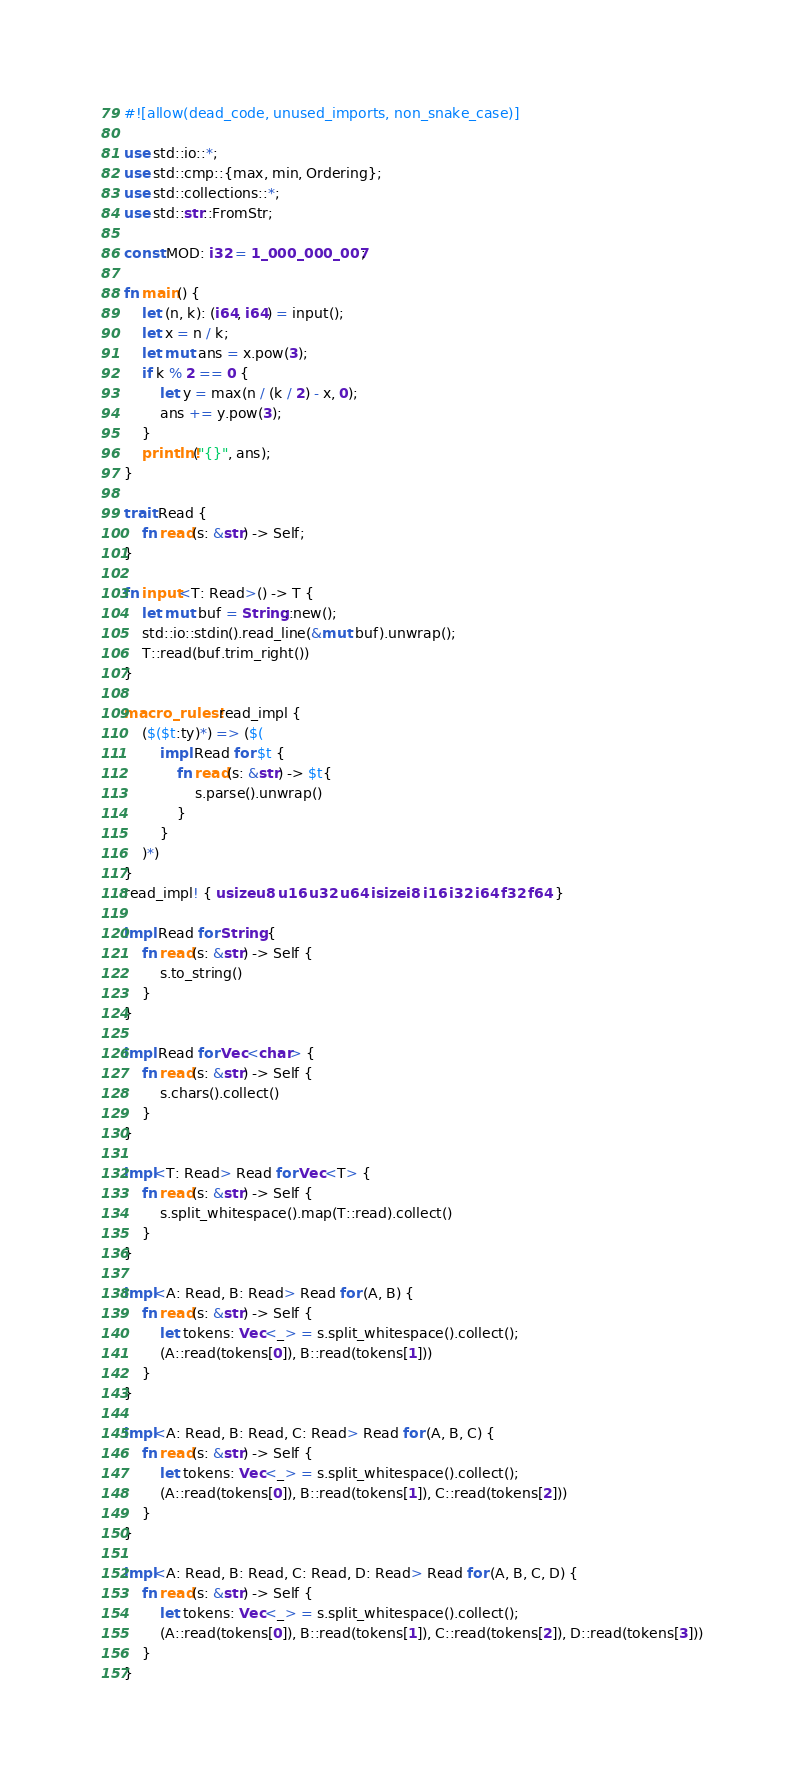Convert code to text. <code><loc_0><loc_0><loc_500><loc_500><_Rust_>#![allow(dead_code, unused_imports, non_snake_case)]

use std::io::*;
use std::cmp::{max, min, Ordering};
use std::collections::*;
use std::str::FromStr;

const MOD: i32 = 1_000_000_007;

fn main() {
    let (n, k): (i64, i64) = input();
    let x = n / k;
    let mut ans = x.pow(3);
    if k % 2 == 0 {
        let y = max(n / (k / 2) - x, 0);
        ans += y.pow(3);
    }
    println!("{}", ans);
}

trait Read {
    fn read(s: &str) -> Self;
}

fn input<T: Read>() -> T {
    let mut buf = String::new();
    std::io::stdin().read_line(&mut buf).unwrap();
    T::read(buf.trim_right())
}

macro_rules! read_impl {
    ($($t:ty)*) => ($(
        impl Read for $t {
            fn read(s: &str) -> $t{
                s.parse().unwrap()
            }
        }
    )*)
}
read_impl! { usize u8 u16 u32 u64 isize i8 i16 i32 i64 f32 f64 }

impl Read for String {
    fn read(s: &str) -> Self {
        s.to_string()
    }
}

impl Read for Vec<char> {
    fn read(s: &str) -> Self {
        s.chars().collect()
    }
}

impl<T: Read> Read for Vec<T> {
    fn read(s: &str) -> Self {
        s.split_whitespace().map(T::read).collect()
    }
}

impl<A: Read, B: Read> Read for (A, B) {
    fn read(s: &str) -> Self {
        let tokens: Vec<_> = s.split_whitespace().collect();
        (A::read(tokens[0]), B::read(tokens[1]))
    }
}

impl<A: Read, B: Read, C: Read> Read for (A, B, C) {
    fn read(s: &str) -> Self {
        let tokens: Vec<_> = s.split_whitespace().collect();
        (A::read(tokens[0]), B::read(tokens[1]), C::read(tokens[2]))
    }
}

impl<A: Read, B: Read, C: Read, D: Read> Read for (A, B, C, D) {
    fn read(s: &str) -> Self {
        let tokens: Vec<_> = s.split_whitespace().collect();
        (A::read(tokens[0]), B::read(tokens[1]), C::read(tokens[2]), D::read(tokens[3]))
    }
}</code> 